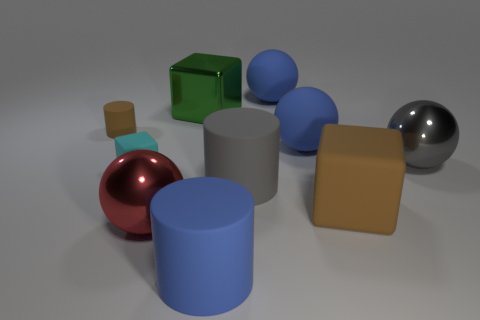There is a brown object that is the same shape as the cyan rubber thing; what is it made of?
Provide a short and direct response. Rubber. How many things are either blue matte things that are on the right side of the big gray rubber thing or large balls that are in front of the tiny brown thing?
Make the answer very short. 4. There is a small brown rubber thing; is it the same shape as the brown rubber object on the right side of the large green metallic cube?
Provide a short and direct response. No. What shape is the big blue object in front of the large red metal sphere that is right of the cylinder left of the green shiny cube?
Keep it short and to the point. Cylinder. What number of other things are made of the same material as the red object?
Provide a short and direct response. 2. How many things are tiny matte objects that are in front of the small matte cylinder or gray spheres?
Keep it short and to the point. 2. There is a large gray object to the left of the matte block that is to the right of the small cyan rubber cube; what shape is it?
Your answer should be compact. Cylinder. There is a red object to the left of the large green shiny block; is it the same shape as the gray metallic thing?
Your response must be concise. Yes. There is a large metal thing that is in front of the cyan thing; what color is it?
Provide a short and direct response. Red. What number of balls are either big purple rubber objects or rubber objects?
Make the answer very short. 2. 